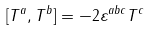<formula> <loc_0><loc_0><loc_500><loc_500>[ T ^ { a } , T ^ { b } ] = - 2 \varepsilon ^ { a b c } T ^ { c }</formula> 